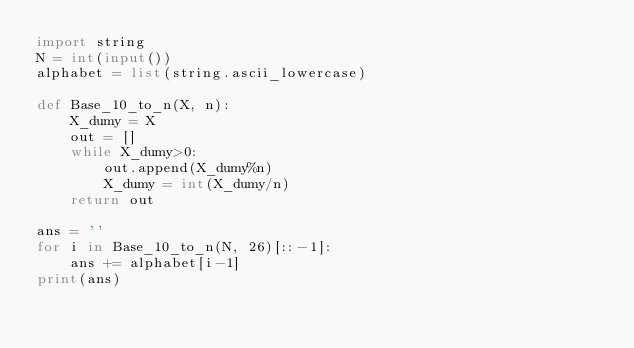Convert code to text. <code><loc_0><loc_0><loc_500><loc_500><_Python_>import string
N = int(input())
alphabet = list(string.ascii_lowercase)

def Base_10_to_n(X, n):
    X_dumy = X
    out = []
    while X_dumy>0:
        out.append(X_dumy%n)
        X_dumy = int(X_dumy/n)
    return out

ans = ''
for i in Base_10_to_n(N, 26)[::-1]:
    ans += alphabet[i-1]
print(ans)</code> 